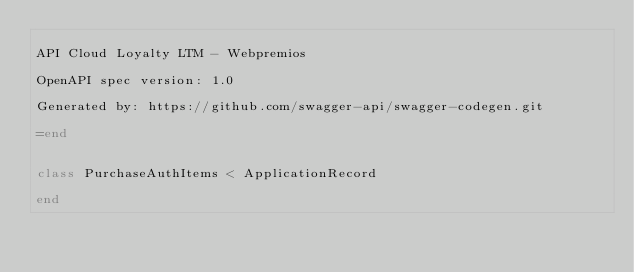Convert code to text. <code><loc_0><loc_0><loc_500><loc_500><_Ruby_>
API Cloud Loyalty LTM - Webpremios

OpenAPI spec version: 1.0

Generated by: https://github.com/swagger-api/swagger-codegen.git

=end


class PurchaseAuthItems < ApplicationRecord

end
</code> 